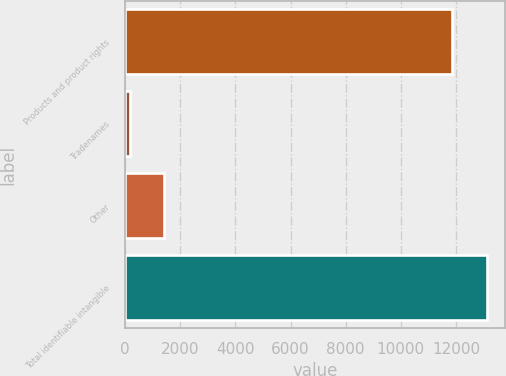Convert chart. <chart><loc_0><loc_0><loc_500><loc_500><bar_chart><fcel>Products and product rights<fcel>Tradenames<fcel>Other<fcel>Total identifiable intangible<nl><fcel>11872<fcel>170<fcel>1425.4<fcel>13127.4<nl></chart> 